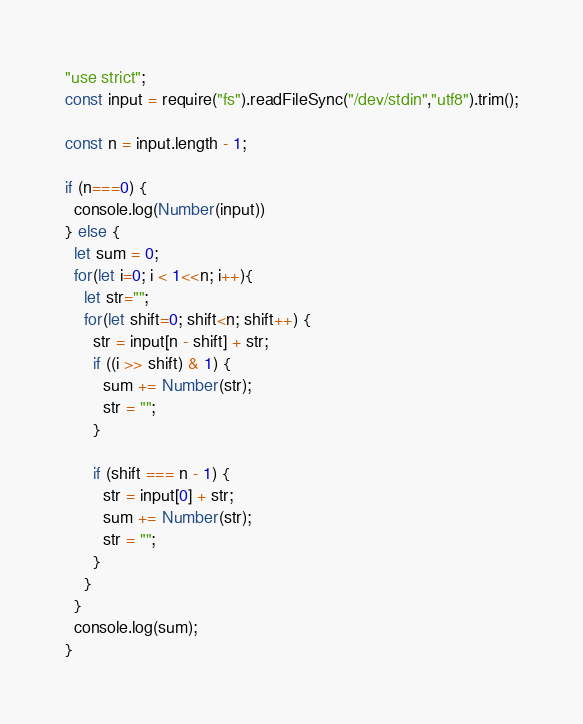Convert code to text. <code><loc_0><loc_0><loc_500><loc_500><_JavaScript_>"use strict";
const input = require("fs").readFileSync("/dev/stdin","utf8").trim();

const n = input.length - 1;

if (n===0) {
  console.log(Number(input))
} else {
  let sum = 0;
  for(let i=0; i < 1<<n; i++){
    let str="";
    for(let shift=0; shift<n; shift++) {
      str = input[n - shift] + str;
      if ((i >> shift) & 1) {
        sum += Number(str);
        str = "";
      }

      if (shift === n - 1) {
        str = input[0] + str;
        sum += Number(str);
        str = "";
      }
    }
  }
  console.log(sum);
}</code> 